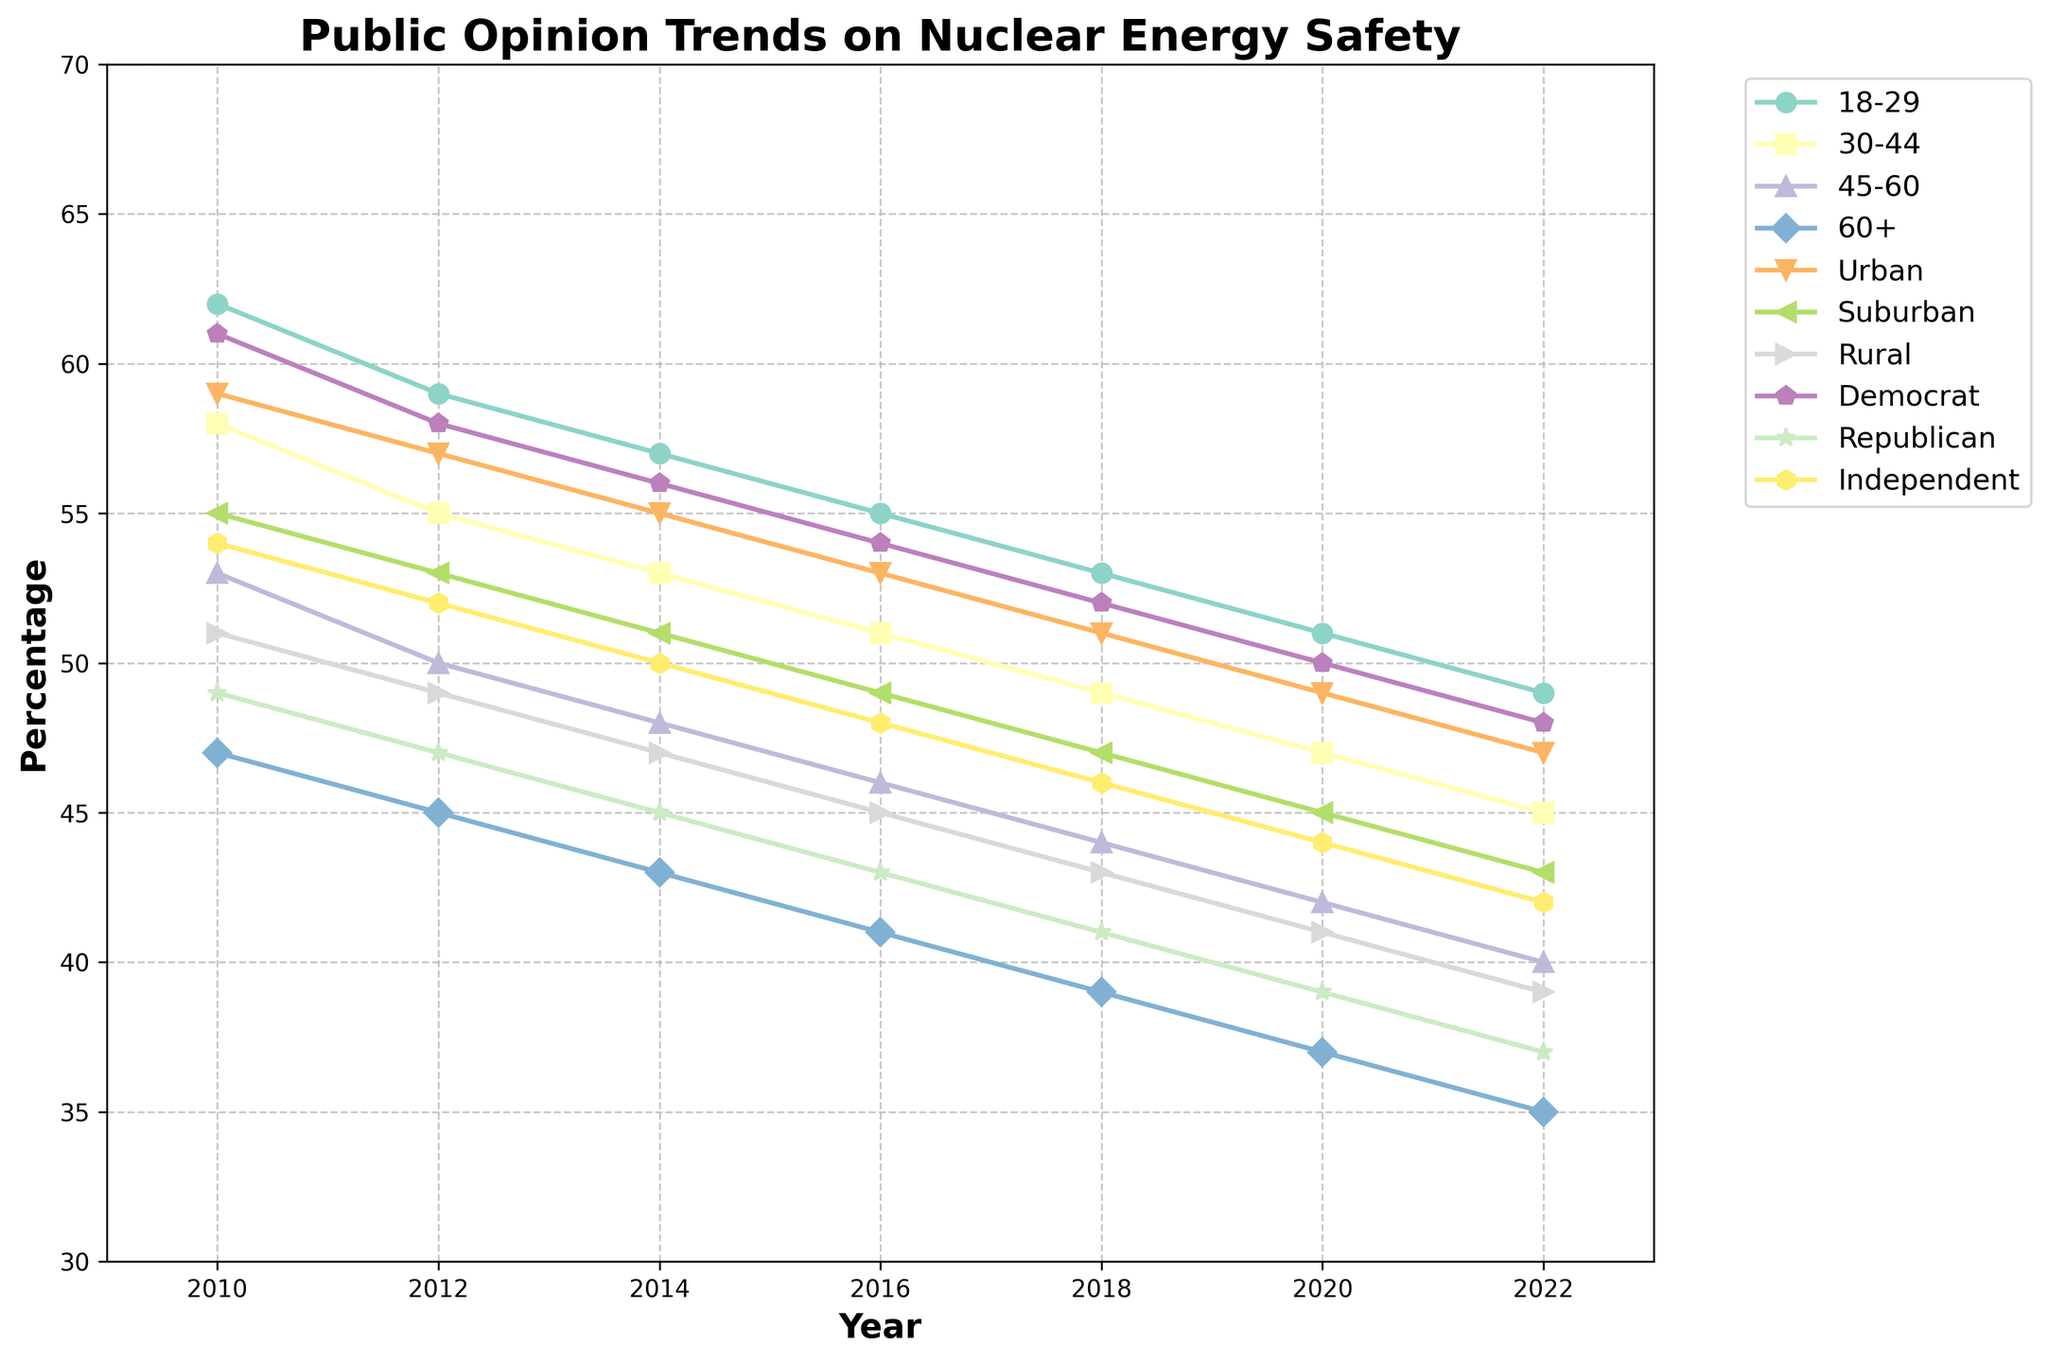Which demographic group shows the most consistent decline in their opinion on nuclear energy safety from 2010 to 2022? The group with the most consistent decline will have a steady downward trend in their line. By inspecting the plot, it appears all groups declined, but the 60+ age group shows a very consistent and steep decline.
Answer: 60+ age group What was the percentage difference in opinion between Democrats and Republicans in 2022? First, find the values for Democrats and Republicans in 2022 on the y-axis. For Democrats, it is 48%, and for Republicans, it is 37%. Subtract the smaller value from the larger one (48% - 37%).
Answer: 11% How does the opinion of rural residents compare to suburban residents over the years? To answer this, look at the trend lines for rural and suburban residents. Both lines generally decline, but the rural residents consistently have a lower percentage compared to suburban residents for each year.
Answer: Rural residents have a consistently lower percentage Which demographic group showed the highest percentage in 2010? Look at the y-axis values for each demographic in 2010. The highest point in 2010 belongs to the 18-29 age group with 62%.
Answer: 18-29 age group What is the average percentage across all demographic groups for the year 2016? Find the percentages for 18-29, 30-44, 45-60, 60+, Urban, Suburban, Rural, Democrat, Republican, and Independent in 2016. Sum these values and divide by the number of groups: (55+51+46+41+53+49+45+54+43+48)/10 = 485/10.
Answer: 48.5% Which group had the smallest decline in their opinion from 2010 to 2022? Calculate the difference for each group from 2010 to 2022. The smallest difference indicates the smallest decline. The 18-29 group dropped from 62% to 49%, which is a 13% decline, which is less than other groups.
Answer: 18-29 age group What trend can be observed in the urban residents' opinion on nuclear energy safety from 2010 to 2022? The urban residents' trend line shows a steady decline from around 59% in 2010 to 47% in 2022.
Answer: Steady decline Are there any demographic groups where the trend lines intersect or are very close at any point? Look at each pair of lines to see if they cross or come very close. The lines for 30-44 and rural residents appear very close around 2014 and 2016.
Answer: 30-44 and rural residents intersect or come very close around 2014-2016 